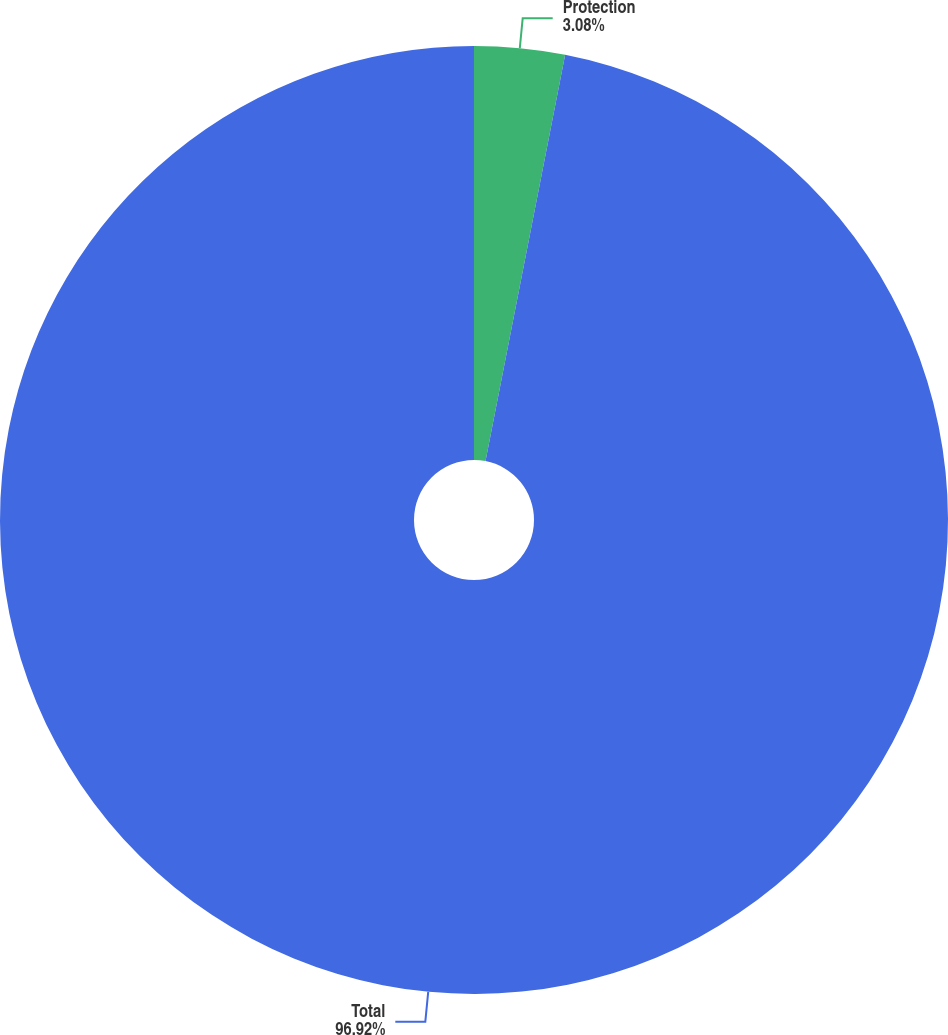Convert chart to OTSL. <chart><loc_0><loc_0><loc_500><loc_500><pie_chart><fcel>Protection<fcel>Total<nl><fcel>3.08%<fcel>96.92%<nl></chart> 